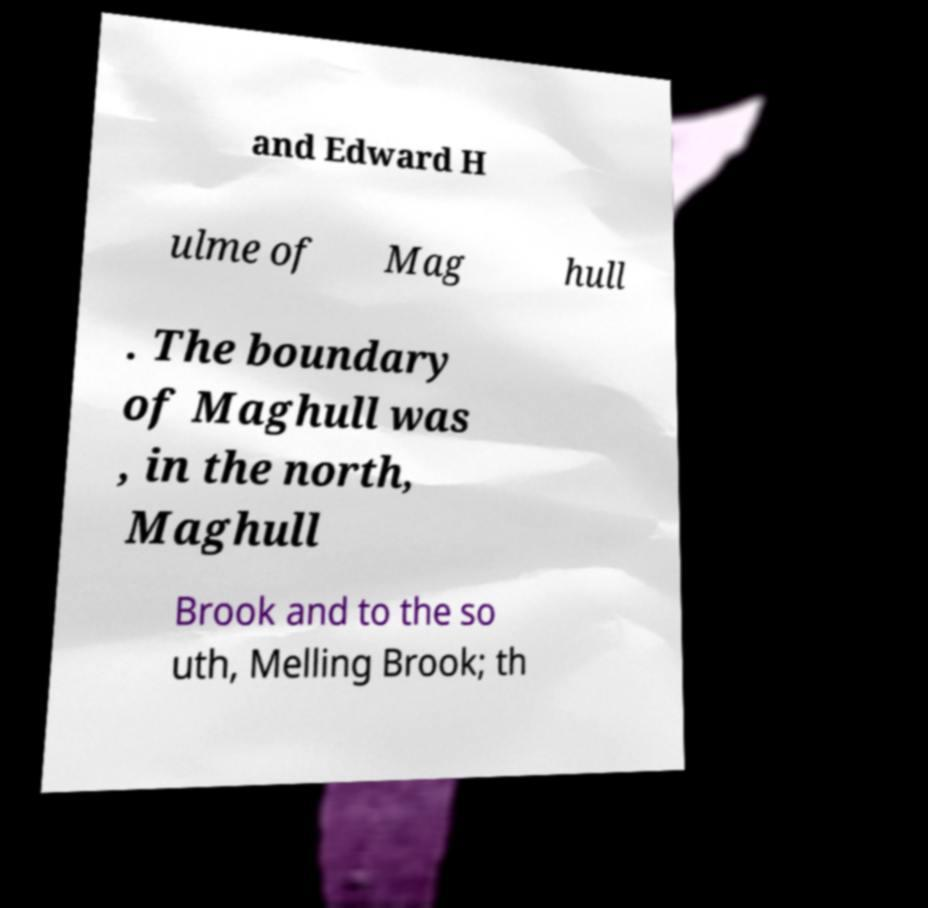Can you accurately transcribe the text from the provided image for me? and Edward H ulme of Mag hull . The boundary of Maghull was , in the north, Maghull Brook and to the so uth, Melling Brook; th 